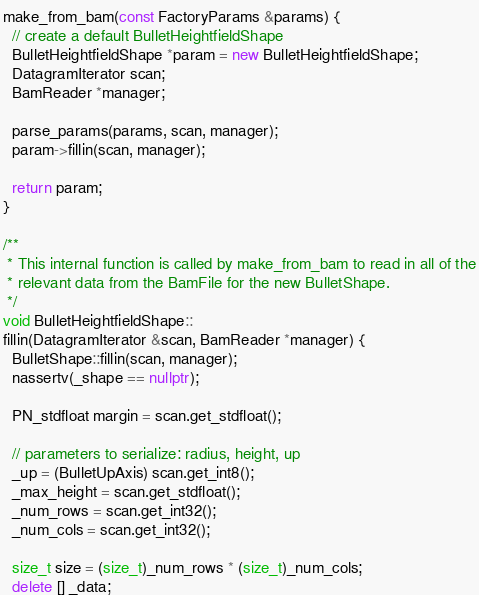<code> <loc_0><loc_0><loc_500><loc_500><_C++_>make_from_bam(const FactoryParams &params) {
  // create a default BulletHeightfieldShape
  BulletHeightfieldShape *param = new BulletHeightfieldShape;
  DatagramIterator scan;
  BamReader *manager;

  parse_params(params, scan, manager);
  param->fillin(scan, manager);

  return param;
}

/**
 * This internal function is called by make_from_bam to read in all of the
 * relevant data from the BamFile for the new BulletShape.
 */
void BulletHeightfieldShape::
fillin(DatagramIterator &scan, BamReader *manager) {
  BulletShape::fillin(scan, manager);
  nassertv(_shape == nullptr);

  PN_stdfloat margin = scan.get_stdfloat();

  // parameters to serialize: radius, height, up
  _up = (BulletUpAxis) scan.get_int8();
  _max_height = scan.get_stdfloat();
  _num_rows = scan.get_int32();
  _num_cols = scan.get_int32();

  size_t size = (size_t)_num_rows * (size_t)_num_cols;
  delete [] _data;</code> 